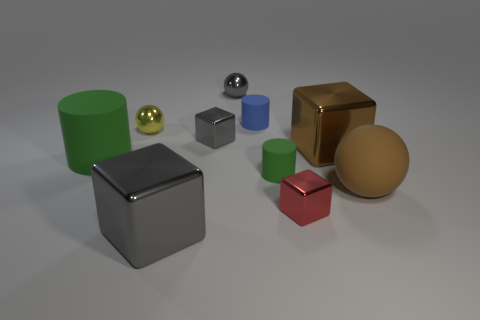Can you describe the lighting of the scene? The scene is lit with a soft overhead light that creates gentle shadows under each object, highlighting their shapes and the reflective properties of their surfaces. 